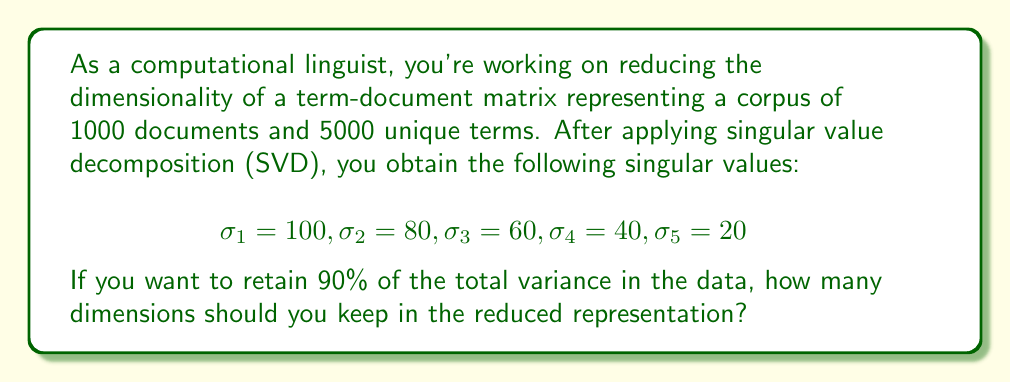Can you answer this question? To solve this problem, we'll follow these steps:

1) First, calculate the total variance in the data. In SVD, the total variance is the sum of the squares of all singular values:

   $$\text{Total Variance} = \sum_{i=1}^n \sigma_i^2$$

   $$\text{Total Variance} = 100^2 + 80^2 + 60^2 + 40^2 + 20^2 = 24,400$$

2) Calculate 90% of the total variance:

   $$0.90 \times 24,400 = 21,960$$

3) Now, we need to find how many dimensions we need to keep to retain at least this much variance. We'll add the squared singular values one by one until we reach or exceed 21,960:

   $$\sigma_1^2 = 100^2 = 10,000$$
   $$\sigma_1^2 + \sigma_2^2 = 100^2 + 80^2 = 16,400$$
   $$\sigma_1^2 + \sigma_2^2 + \sigma_3^2 = 100^2 + 80^2 + 60^2 = 20,000$$
   $$\sigma_1^2 + \sigma_2^2 + \sigma_3^2 + \sigma_4^2 = 100^2 + 80^2 + 60^2 + 40^2 = 21,600$$
   $$\sigma_1^2 + \sigma_2^2 + \sigma_3^2 + \sigma_4^2 + \sigma_5^2 = 100^2 + 80^2 + 60^2 + 40^2 + 20^2 = 24,400$$

4) We see that we need to include the first 5 dimensions to exceed 90% of the total variance.

Therefore, you should keep 5 dimensions in the reduced representation to retain at least 90% of the total variance in the data.
Answer: 5 dimensions 